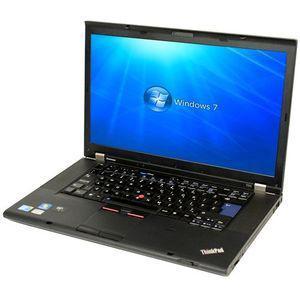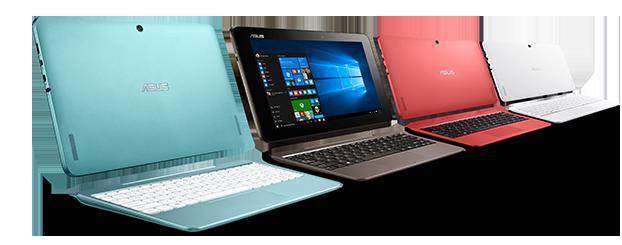The first image is the image on the left, the second image is the image on the right. For the images shown, is this caption "Each image shows a single open laptop, and each laptop is open to an angle of at least 90 degrees." true? Answer yes or no. No. The first image is the image on the left, the second image is the image on the right. Evaluate the accuracy of this statement regarding the images: "some keyboards have white/gray keys.". Is it true? Answer yes or no. Yes. 